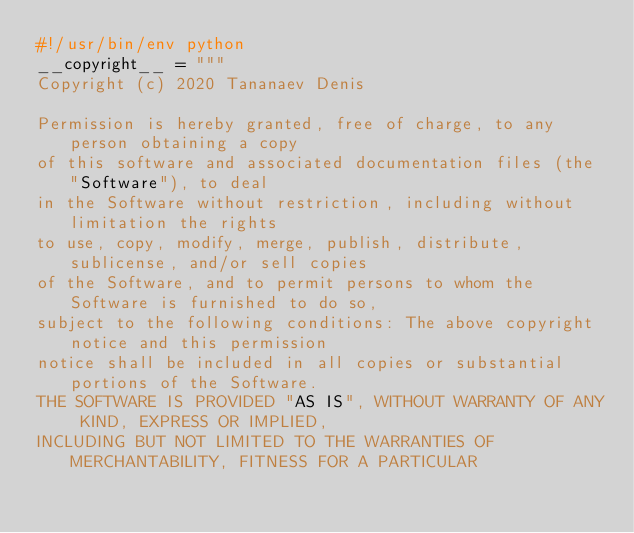Convert code to text. <code><loc_0><loc_0><loc_500><loc_500><_Python_>#!/usr/bin/env python
__copyright__ = """
Copyright (c) 2020 Tananaev Denis

Permission is hereby granted, free of charge, to any person obtaining a copy
of this software and associated documentation files (the "Software"), to deal
in the Software without restriction, including without limitation the rights
to use, copy, modify, merge, publish, distribute, sublicense, and/or sell copies
of the Software, and to permit persons to whom the Software is furnished to do so,
subject to the following conditions: The above copyright notice and this permission
notice shall be included in all copies or substantial portions of the Software.
THE SOFTWARE IS PROVIDED "AS IS", WITHOUT WARRANTY OF ANY KIND, EXPRESS OR IMPLIED,
INCLUDING BUT NOT LIMITED TO THE WARRANTIES OF MERCHANTABILITY, FITNESS FOR A PARTICULAR</code> 